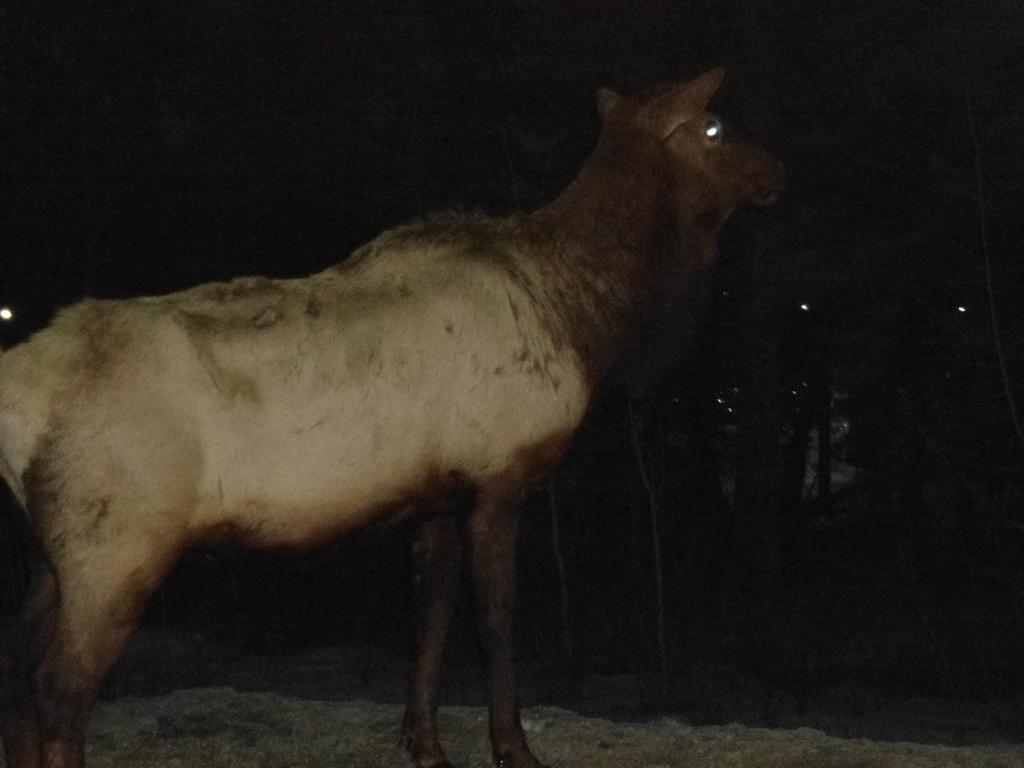In one or two sentences, can you explain what this image depicts? In this image there is a dear. 